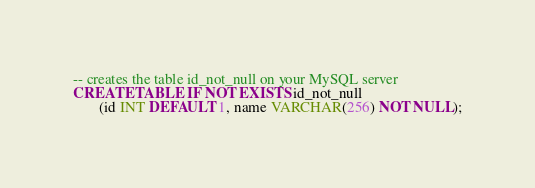Convert code to text. <code><loc_0><loc_0><loc_500><loc_500><_SQL_>-- creates the table id_not_null on your MySQL server
CREATE TABLE IF NOT EXISTS id_not_null
	   (id INT DEFAULT 1, name VARCHAR(256) NOT NULL);
</code> 